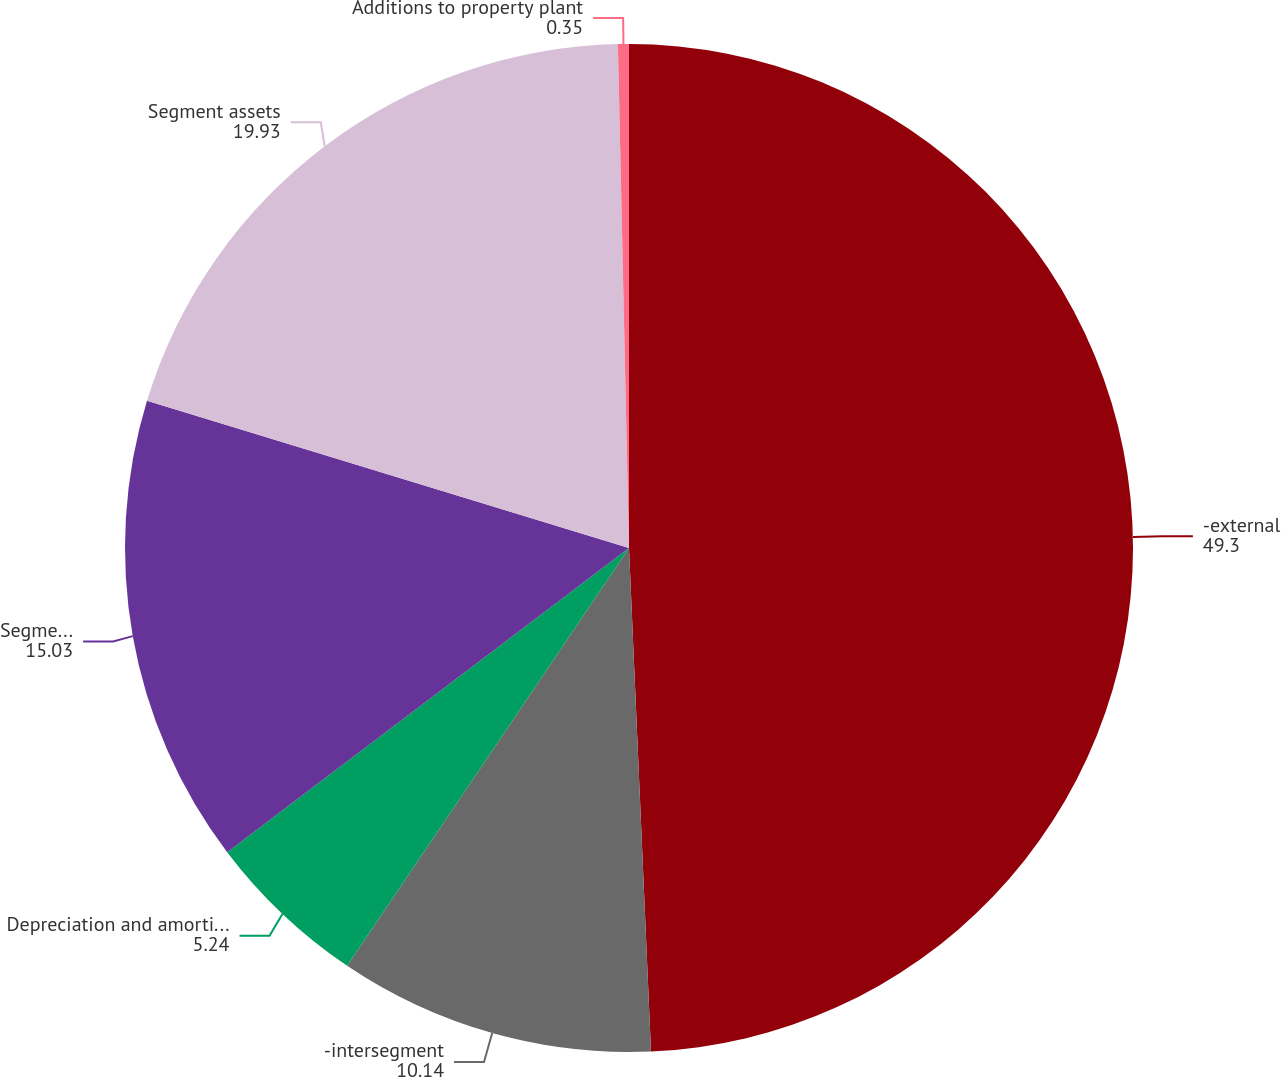Convert chart to OTSL. <chart><loc_0><loc_0><loc_500><loc_500><pie_chart><fcel>-external<fcel>-intersegment<fcel>Depreciation and amortization<fcel>Segment operating income<fcel>Segment assets<fcel>Additions to property plant<nl><fcel>49.3%<fcel>10.14%<fcel>5.24%<fcel>15.03%<fcel>19.93%<fcel>0.35%<nl></chart> 